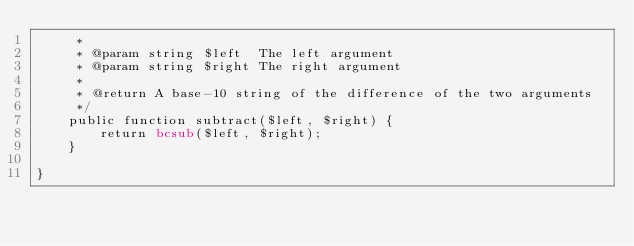Convert code to text. <code><loc_0><loc_0><loc_500><loc_500><_PHP_>     * 
     * @param string $left  The left argument
     * @param string $right The right argument
     * 
     * @return A base-10 string of the difference of the two arguments
     */
    public function subtract($left, $right) {
        return bcsub($left, $right);
    }

}</code> 